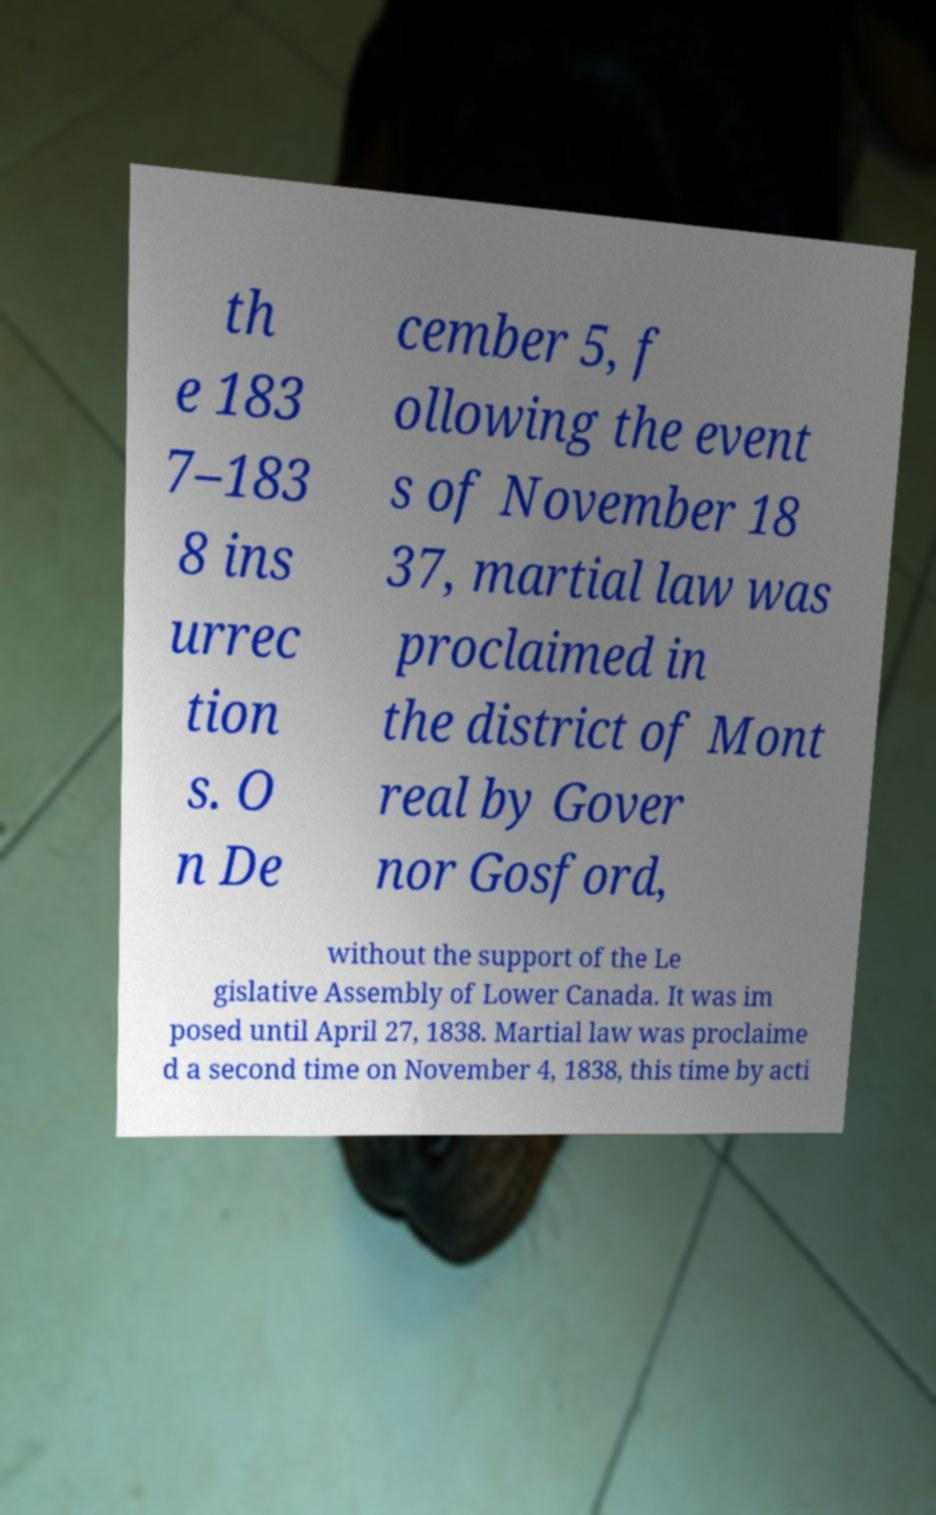There's text embedded in this image that I need extracted. Can you transcribe it verbatim? th e 183 7–183 8 ins urrec tion s. O n De cember 5, f ollowing the event s of November 18 37, martial law was proclaimed in the district of Mont real by Gover nor Gosford, without the support of the Le gislative Assembly of Lower Canada. It was im posed until April 27, 1838. Martial law was proclaime d a second time on November 4, 1838, this time by acti 